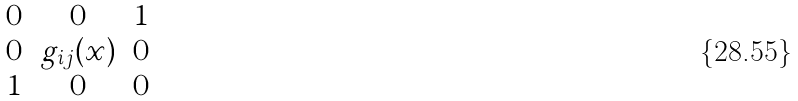Convert formula to latex. <formula><loc_0><loc_0><loc_500><loc_500>\begin{matrix} 0 & 0 & 1 \\ 0 & g _ { i j } ( x ) & 0 \\ 1 & 0 & 0 \end{matrix}</formula> 